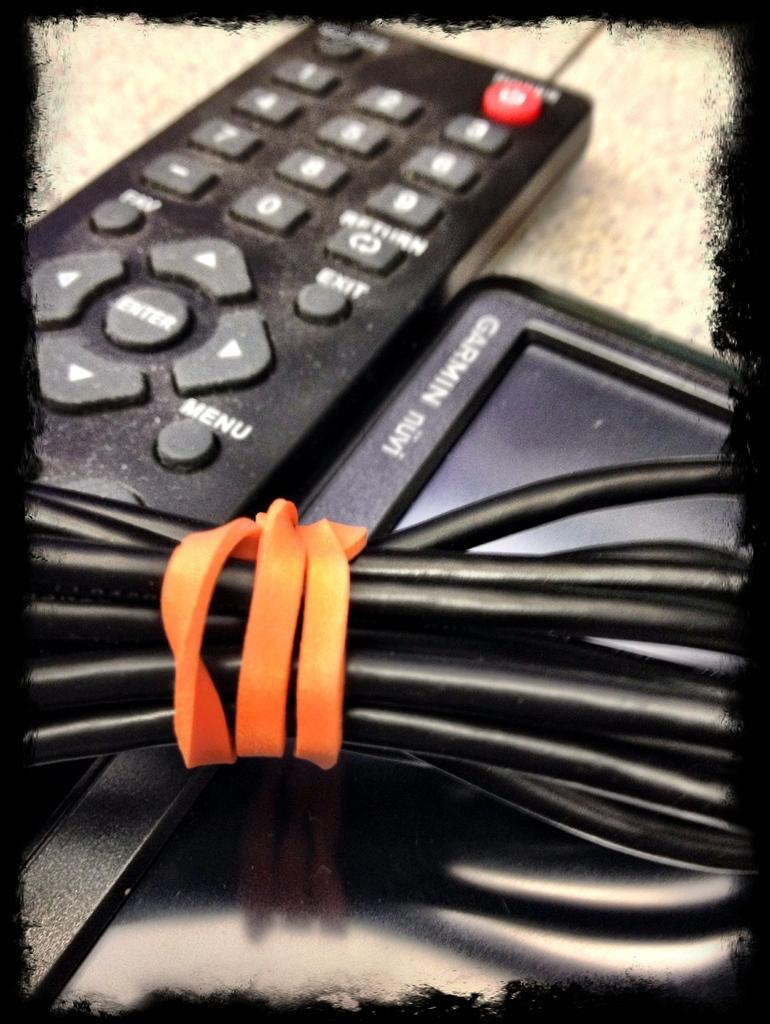<image>
Relay a brief, clear account of the picture shown. A black remote sits next to a small screen that has Garmin on the edge. 